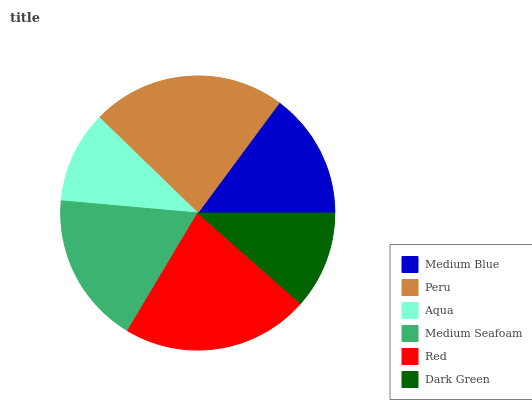Is Aqua the minimum?
Answer yes or no. Yes. Is Peru the maximum?
Answer yes or no. Yes. Is Peru the minimum?
Answer yes or no. No. Is Aqua the maximum?
Answer yes or no. No. Is Peru greater than Aqua?
Answer yes or no. Yes. Is Aqua less than Peru?
Answer yes or no. Yes. Is Aqua greater than Peru?
Answer yes or no. No. Is Peru less than Aqua?
Answer yes or no. No. Is Medium Seafoam the high median?
Answer yes or no. Yes. Is Medium Blue the low median?
Answer yes or no. Yes. Is Red the high median?
Answer yes or no. No. Is Peru the low median?
Answer yes or no. No. 